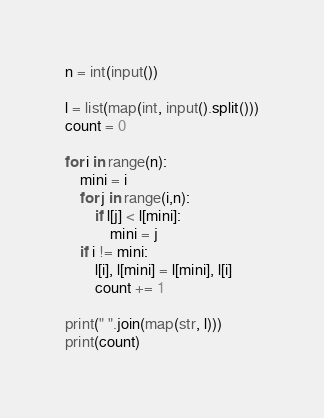<code> <loc_0><loc_0><loc_500><loc_500><_Python_>n = int(input())

l = list(map(int, input().split()))
count = 0

for i in range(n):
    mini = i
    for j in range(i,n):
        if l[j] < l[mini]:
            mini = j
    if i != mini:
        l[i], l[mini] = l[mini], l[i]
        count += 1

print(" ".join(map(str, l)))
print(count)

</code> 